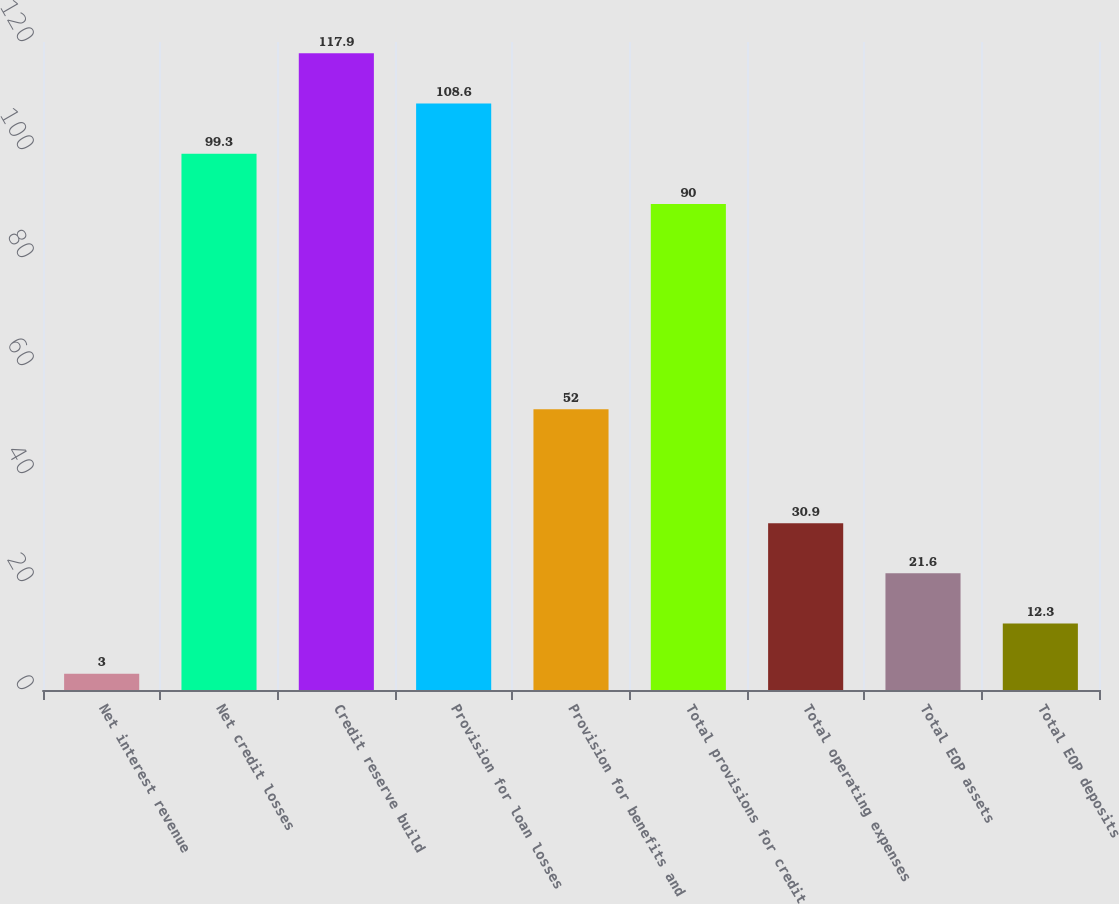<chart> <loc_0><loc_0><loc_500><loc_500><bar_chart><fcel>Net interest revenue<fcel>Net credit losses<fcel>Credit reserve build<fcel>Provision for loan losses<fcel>Provision for benefits and<fcel>Total provisions for credit<fcel>Total operating expenses<fcel>Total EOP assets<fcel>Total EOP deposits<nl><fcel>3<fcel>99.3<fcel>117.9<fcel>108.6<fcel>52<fcel>90<fcel>30.9<fcel>21.6<fcel>12.3<nl></chart> 